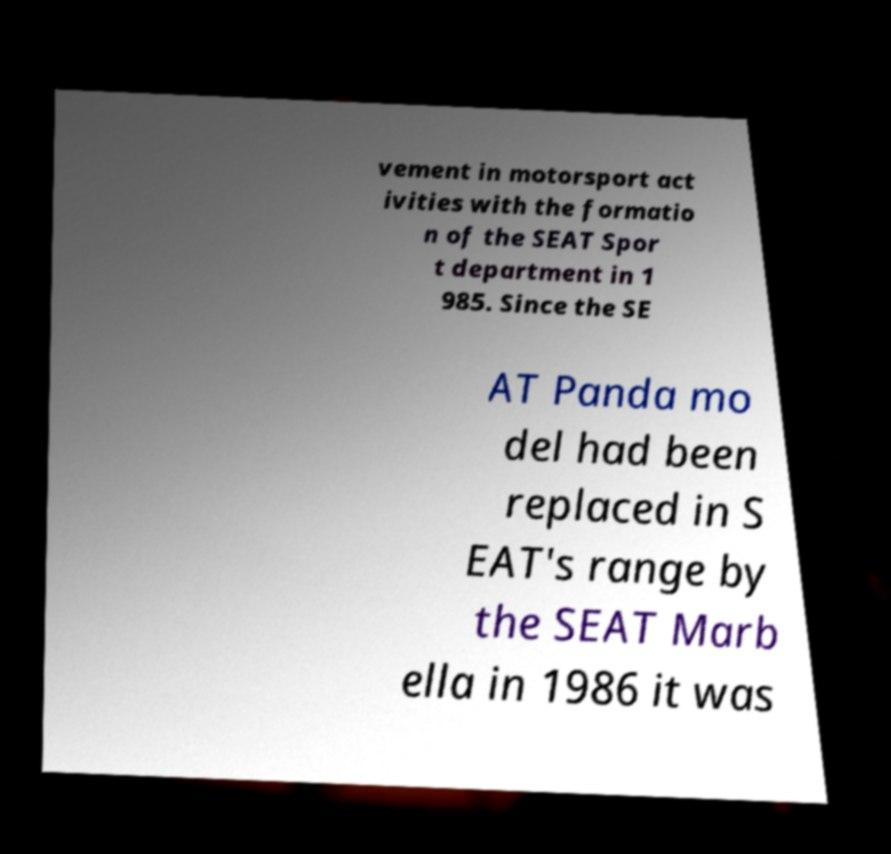Please identify and transcribe the text found in this image. vement in motorsport act ivities with the formatio n of the SEAT Spor t department in 1 985. Since the SE AT Panda mo del had been replaced in S EAT's range by the SEAT Marb ella in 1986 it was 